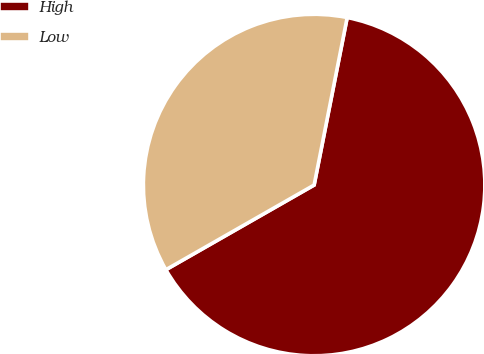Convert chart. <chart><loc_0><loc_0><loc_500><loc_500><pie_chart><fcel>High<fcel>Low<nl><fcel>63.64%<fcel>36.36%<nl></chart> 